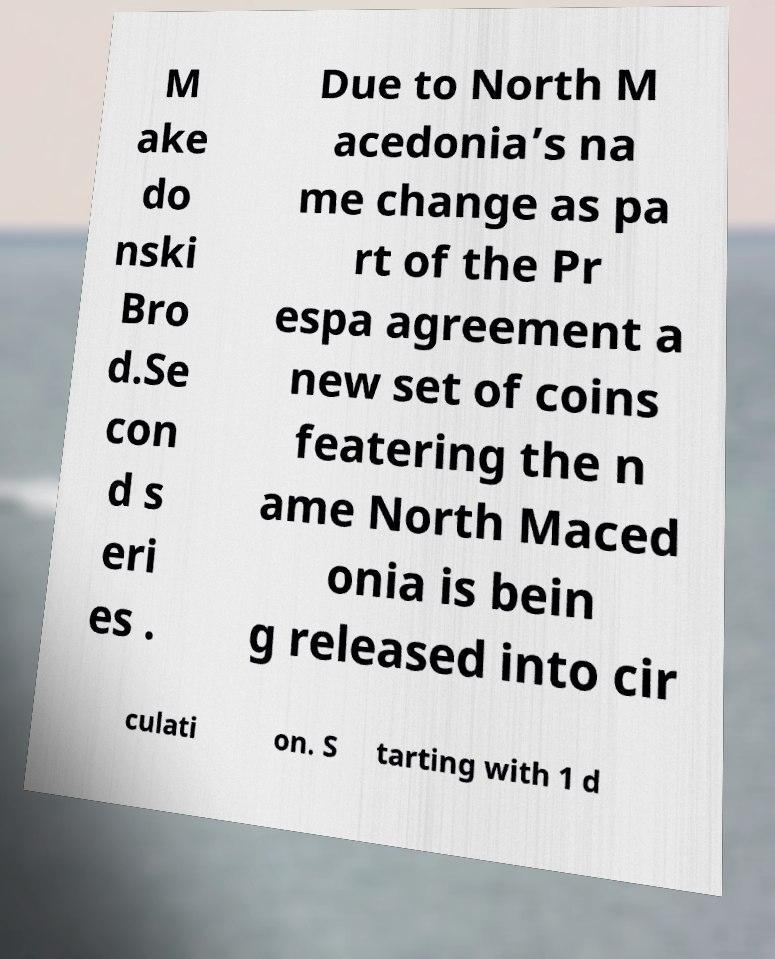What messages or text are displayed in this image? I need them in a readable, typed format. M ake do nski Bro d.Se con d s eri es . Due to North M acedonia’s na me change as pa rt of the Pr espa agreement a new set of coins featering the n ame North Maced onia is bein g released into cir culati on. S tarting with 1 d 